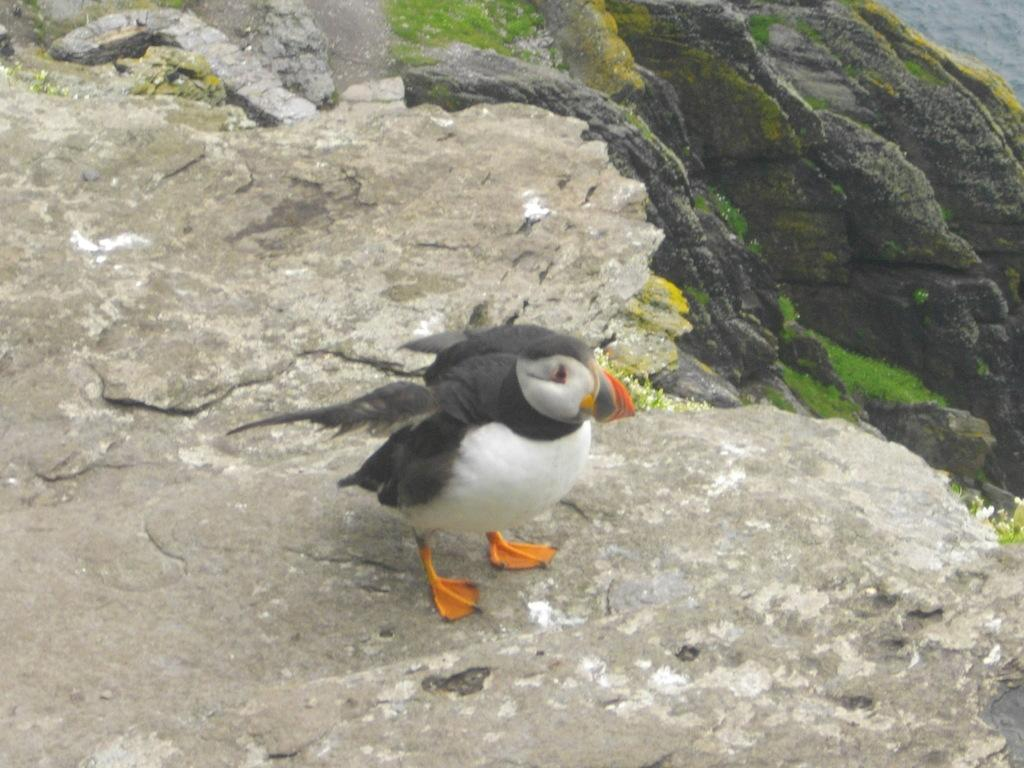What is the main subject of the image? There is a bird in the center of the image. Can you identify the species of the bird? The bird appears to be an Atlantic puffin. What can be seen in the background of the image? There are rocks and a portion of green grass visible in the background of the image. What type of picture is the bird drawing with chalk in the image? There is no picture or chalk present in the image; it features a bird in the center of the image. How many hands does the bird have in the image? Birds do not have hands, and there is no indication of any hands in the image. 